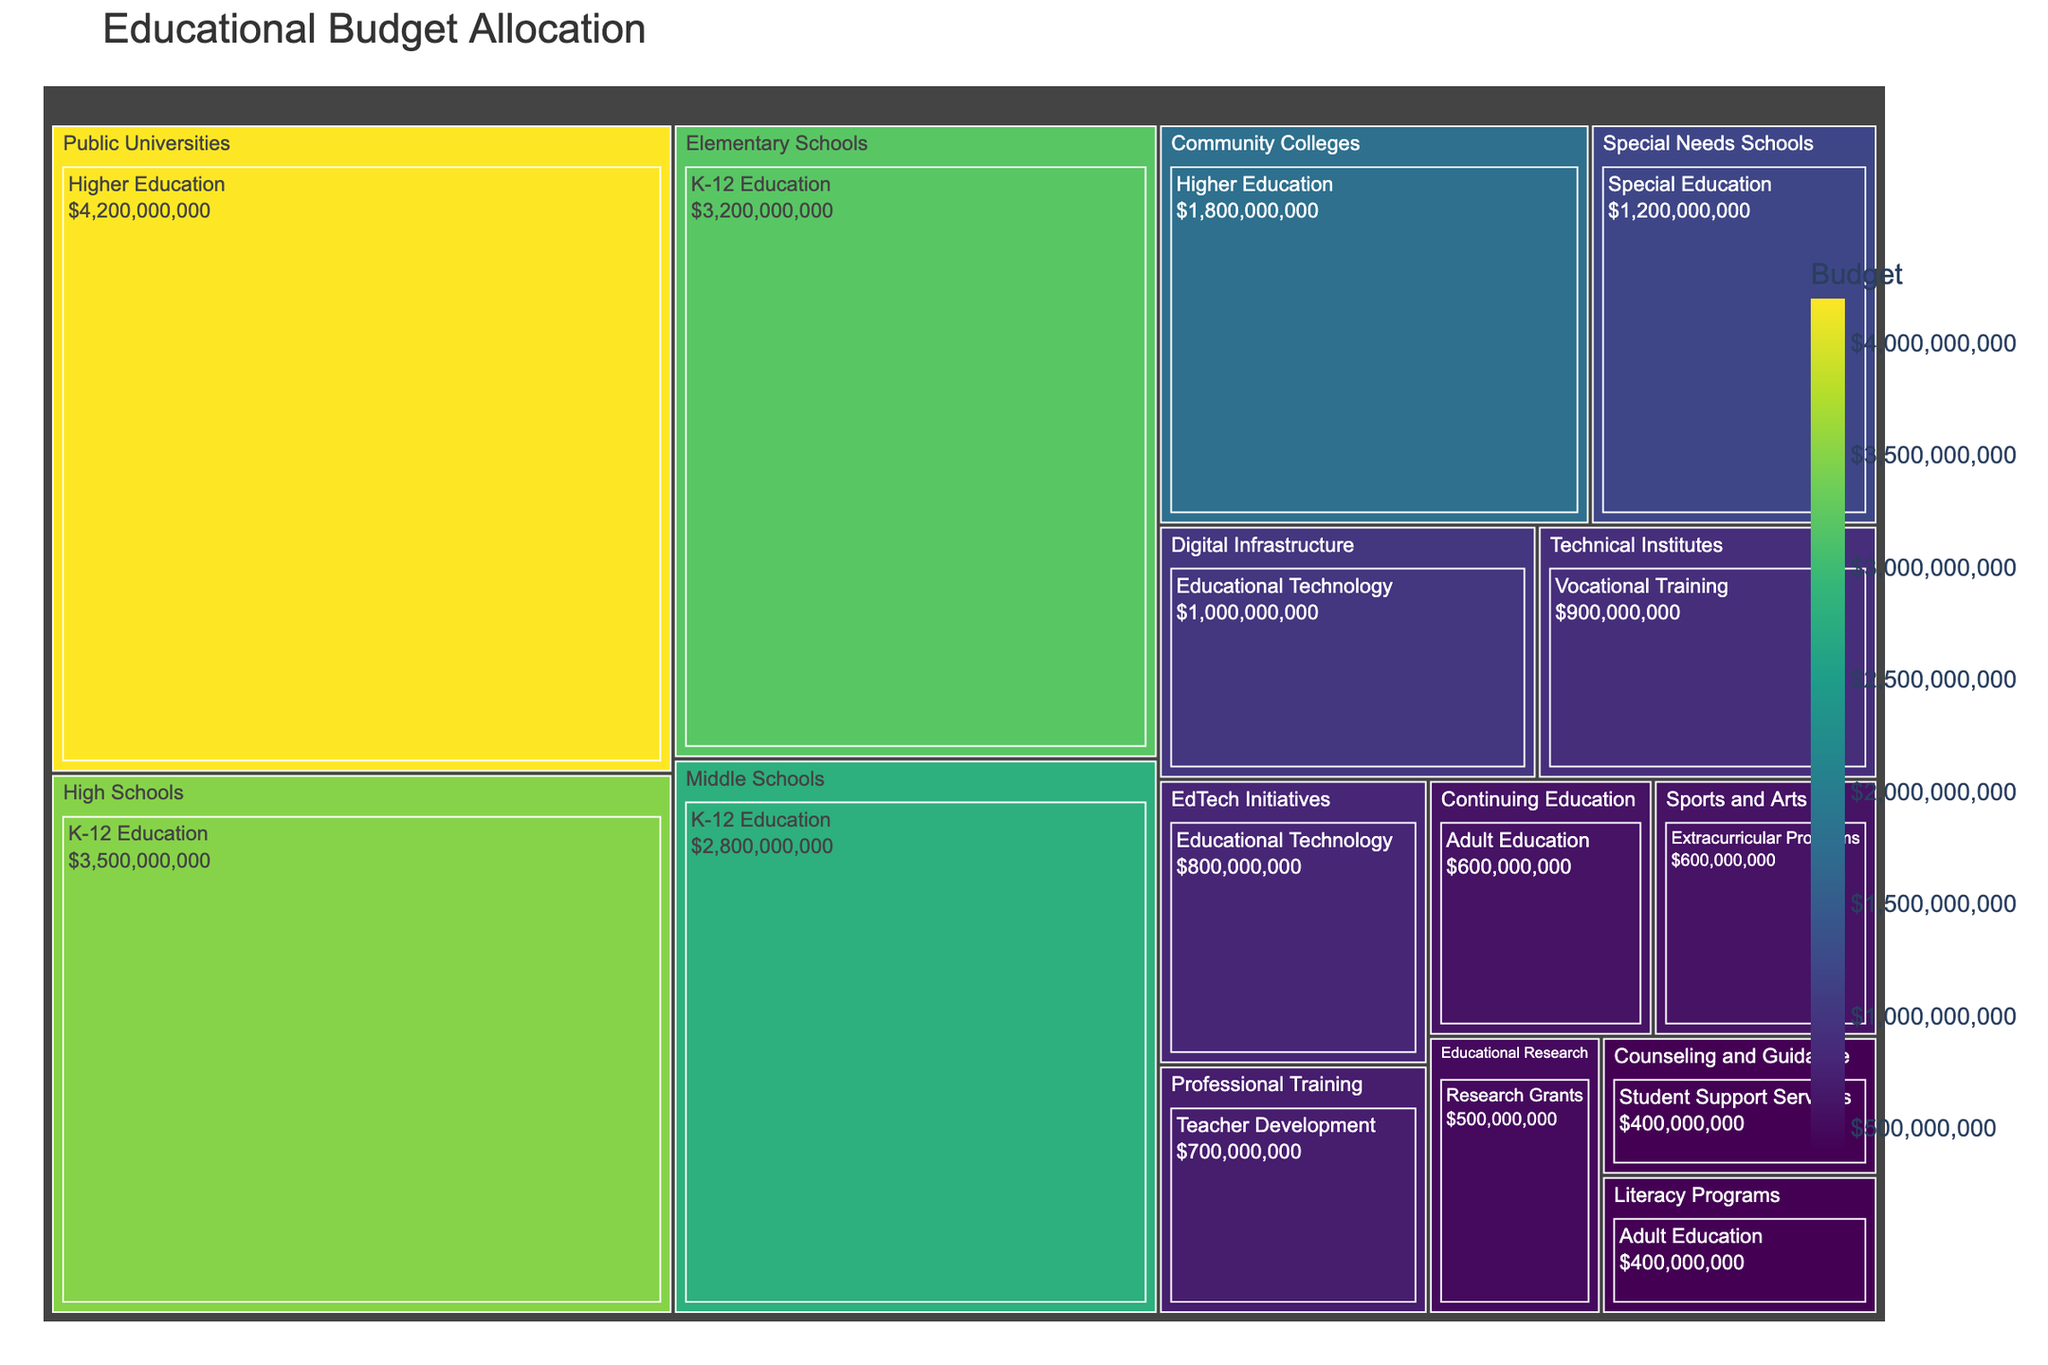What's the title of the treemap? The title is displayed at the top of the treemap and usually summarizes the main focus of the data being visualized.
Answer: Educational Budget Allocation Which category within K-12 Education has the highest budget? Focus on the K-12 Education sector and compare the budgets among Elementary Schools, Middle Schools, and High Schools. High Schools have the highest budget.
Answer: High Schools What's the sum of the budgets for Adult Education categories? Find the budgets for Literacy Programs and Continuing Education, then sum them: $400,000,000 + $600,000,000 = $1,000,000,000.
Answer: $1,000,000,000 How does the budget for Public Universities compare to that for Elementary Schools? Locate the budgets for Public Universities and Elementary Schools and compare them. Public Universities have $4,200,000,000 while Elementary Schools have $3,200,000,000. The former is higher.
Answer: Public Universities have a higher budget Which category has the lowest budget and what is it? Identify the category with the smallest segment in the treemap and check its budget.
Answer: Counseling and Guidance; $400,000,000 What is the average budget for sectors related to Higher Education? Find the budgets for Public Universities and Community Colleges, sum them up and divide by 2: ($4,200,000,000 + $1,800,000,000)/2 = $3,000,000,000.
Answer: $3,000,000,000 Which sector has the highest budget allocation among all sectors? Look for the sector with the largest segment in the treemap and check its budget. Higher Education has the highest overall budget.
Answer: Higher Education How much more is allocated to High Schools than Middle Schools? Subtract the budget of Middle Schools from that of High Schools: $3,500,000,000 - $2,800,000,000 = $700,000,000.
Answer: $700,000,000 What percentage of the total budget is allocated to Special Needs Schools? Calculate the total budget by summing all sectors, then find the percentage for Special Needs Schools.
Answer: ( $1,200,000,000 / $17,900,000,000 ) * 100 ≈ 6.7% 